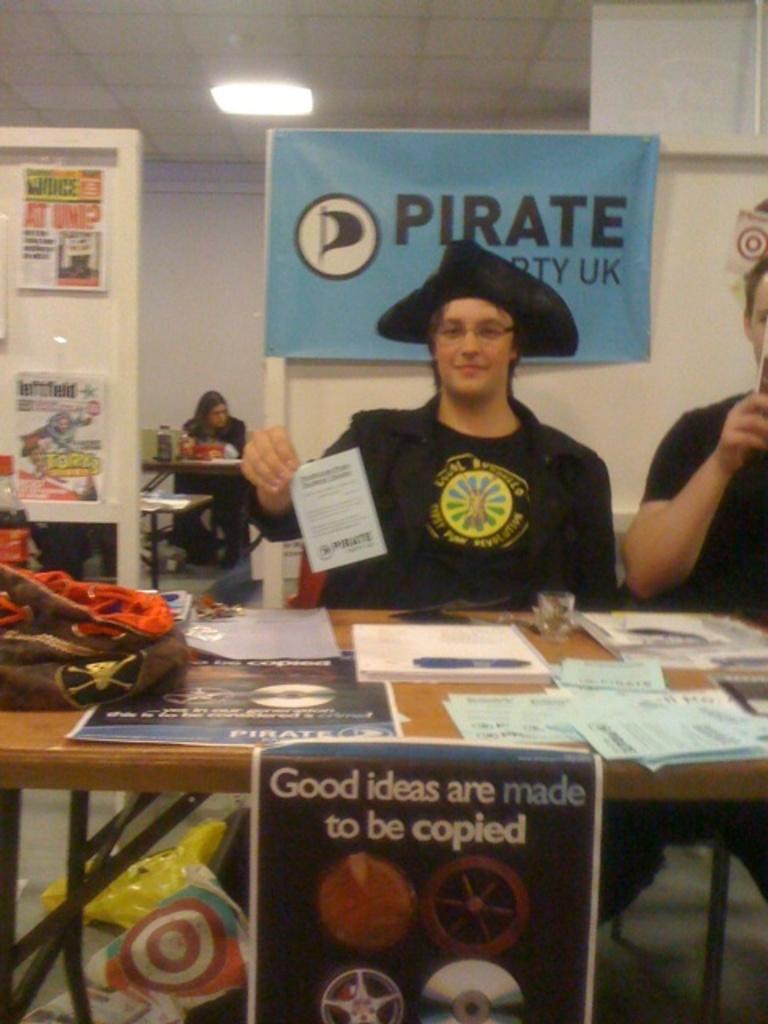What is written on the blue sign?
Provide a succinct answer. Pirate. 